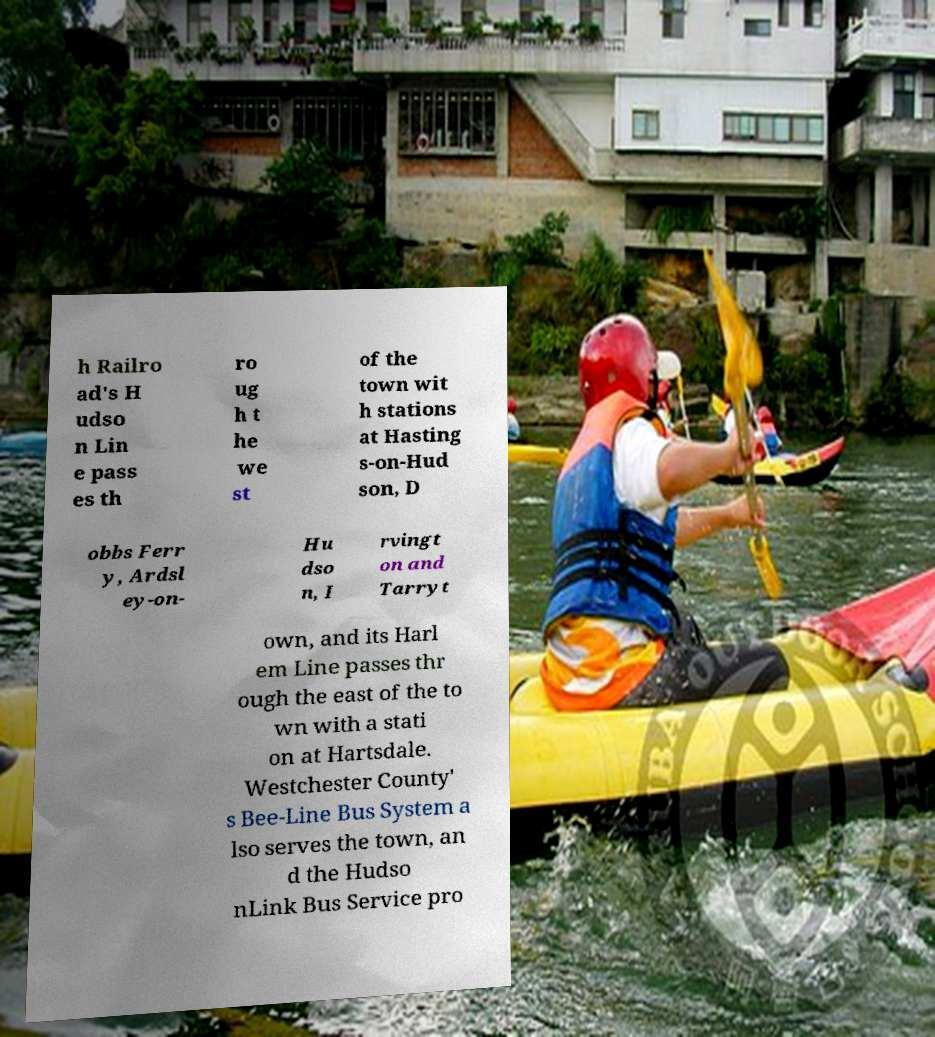Could you extract and type out the text from this image? h Railro ad's H udso n Lin e pass es th ro ug h t he we st of the town wit h stations at Hasting s-on-Hud son, D obbs Ferr y, Ardsl ey-on- Hu dso n, I rvingt on and Tarryt own, and its Harl em Line passes thr ough the east of the to wn with a stati on at Hartsdale. Westchester County' s Bee-Line Bus System a lso serves the town, an d the Hudso nLink Bus Service pro 